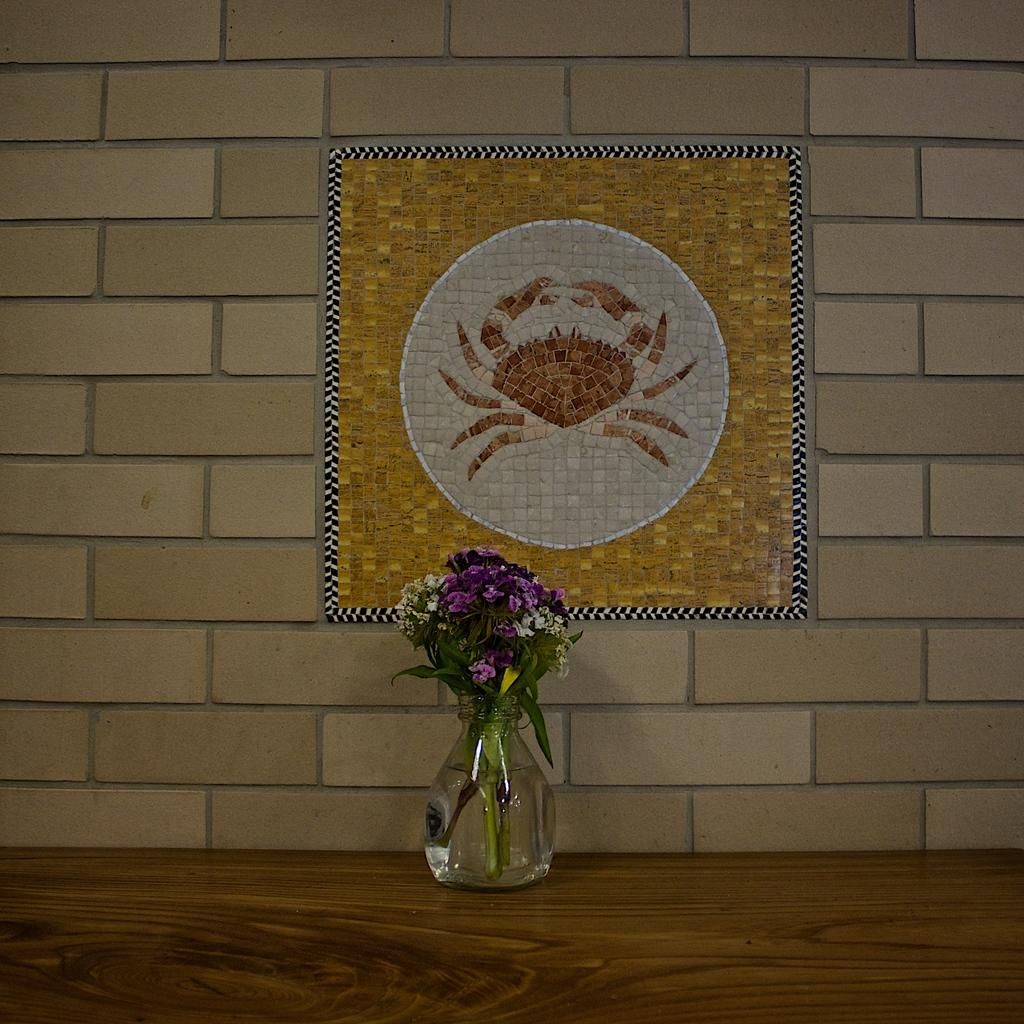What piece of furniture is present in the image? There is a table in the image. What is placed on the table? There is a flower vase on the table. What is inside the flower vase? The flower vase contains flowers. What can be seen in the background of the image? There is a wall in the background of the image. What is the appearance of the wall? The wall has a design on it. How does the sink contribute to the design of the wall in the image? There is no sink present in the image; it only features a table, a flower vase, flowers, and a wall with a design. 